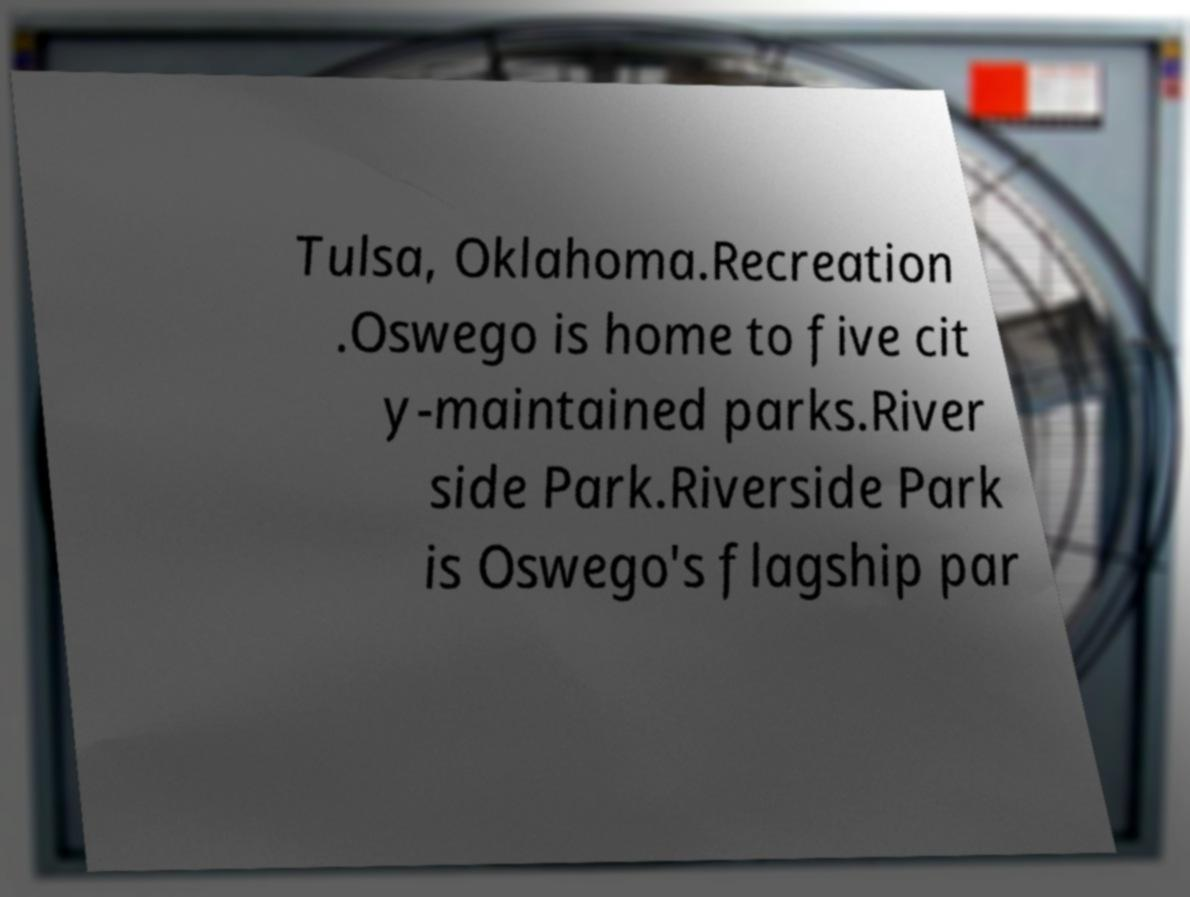I need the written content from this picture converted into text. Can you do that? Tulsa, Oklahoma.Recreation .Oswego is home to five cit y-maintained parks.River side Park.Riverside Park is Oswego's flagship par 